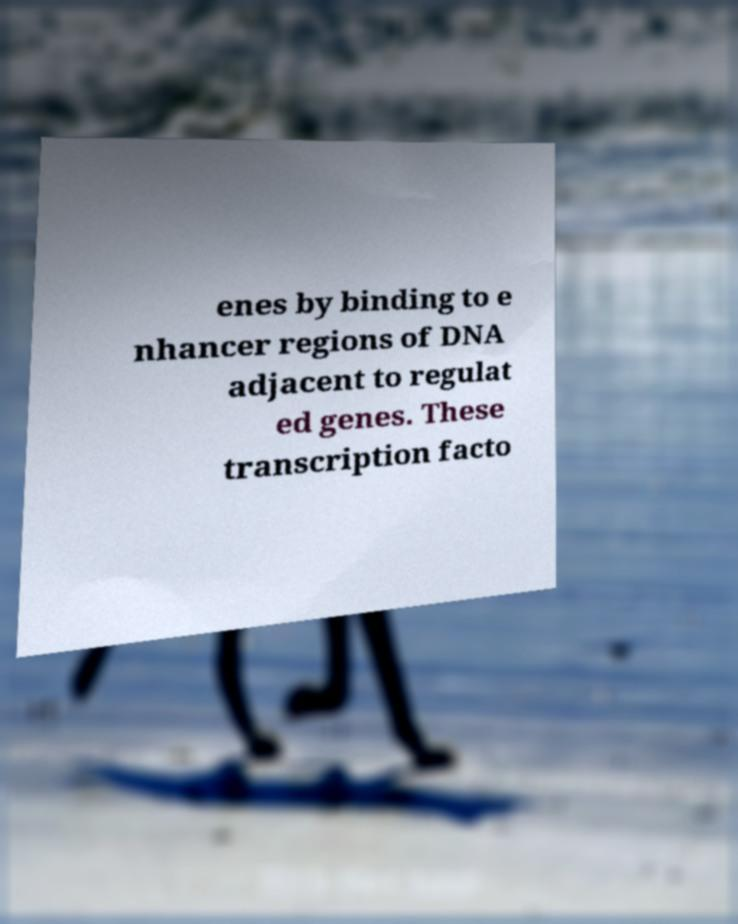There's text embedded in this image that I need extracted. Can you transcribe it verbatim? enes by binding to e nhancer regions of DNA adjacent to regulat ed genes. These transcription facto 